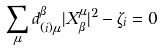<formula> <loc_0><loc_0><loc_500><loc_500>\sum _ { \mu } d _ { ( i ) \mu } ^ { \beta } | X ^ { \mu } _ { \beta } | ^ { 2 } - \zeta _ { i } = 0</formula> 